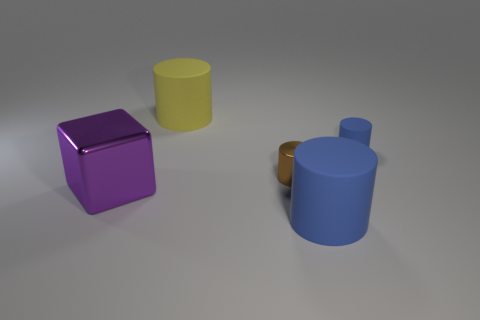Subtract 1 cylinders. How many cylinders are left? 3 Subtract all red cylinders. Subtract all cyan balls. How many cylinders are left? 4 Add 1 blue matte objects. How many objects exist? 6 Subtract all cylinders. How many objects are left? 1 Add 5 brown shiny cylinders. How many brown shiny cylinders are left? 6 Add 5 small brown cylinders. How many small brown cylinders exist? 6 Subtract 0 yellow balls. How many objects are left? 5 Subtract all large objects. Subtract all blue objects. How many objects are left? 0 